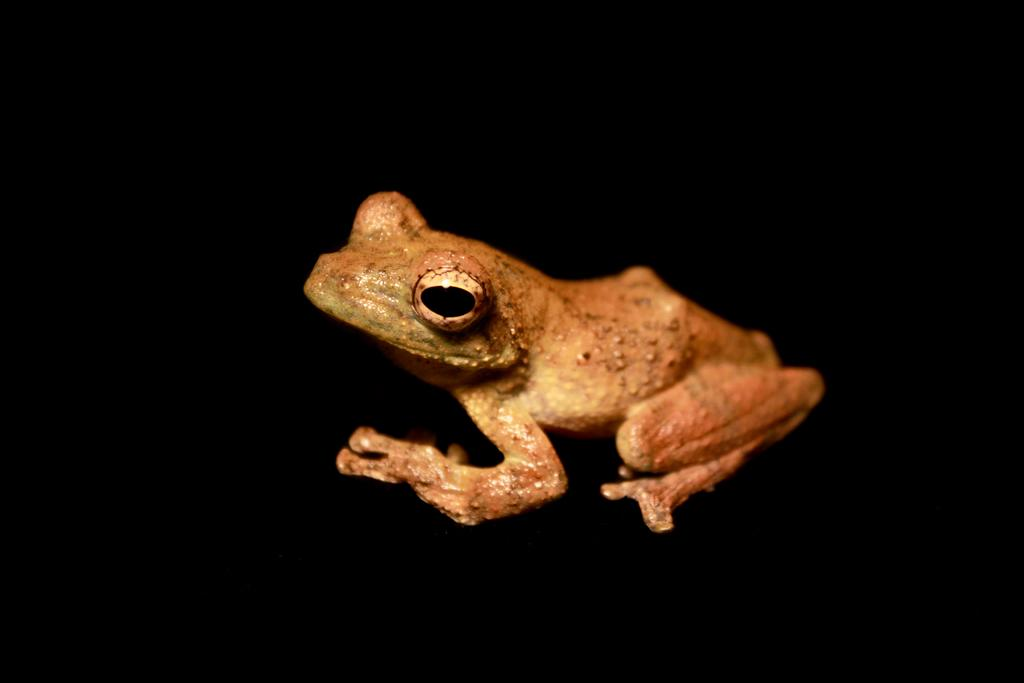What is the main subject of the image? There is a frog in the center of the image. What color is the background of the image? The background of the image is black in color. What type of rule does the frog enforce in the image? There is no indication in the image that the frog is enforcing any rules. 